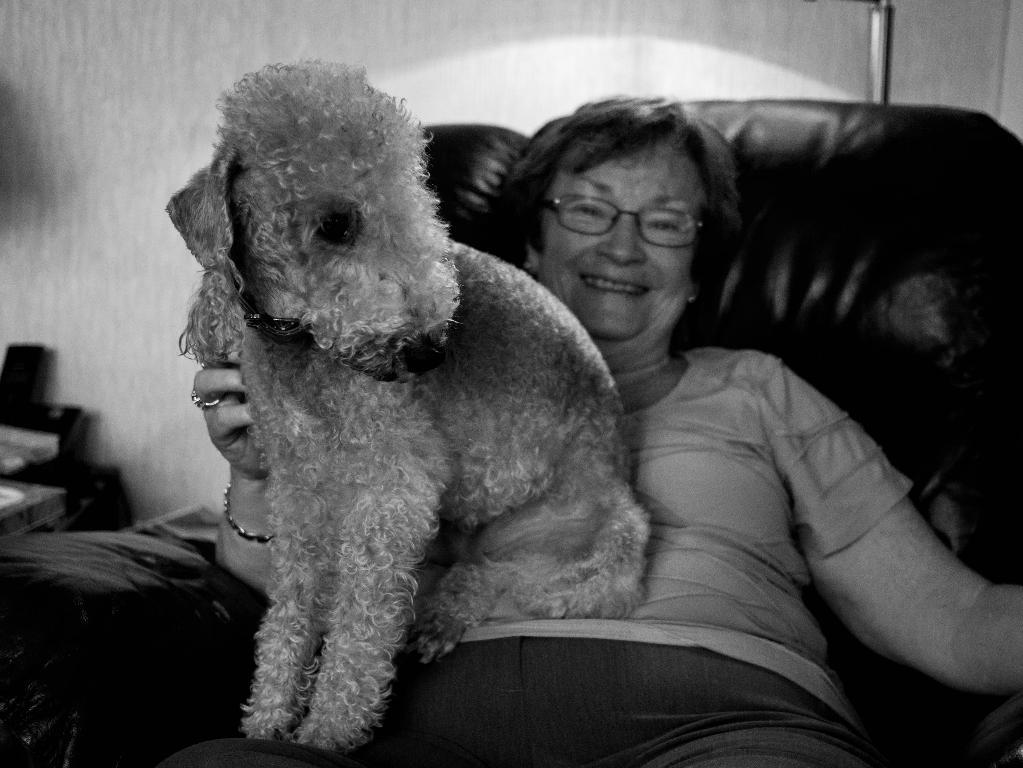Who is present in the image? There is a woman in the image. What is the woman doing in the image? The woman is sitting on a couch. Are there any animals present in the image? Yes, there is a dog in the image. What type of juice is being exchanged between the woman and the dog in the image? There is no juice or exchange between the woman and the dog in the image; the woman is sitting on a couch, and the dog is present, but no interaction is depicted. 